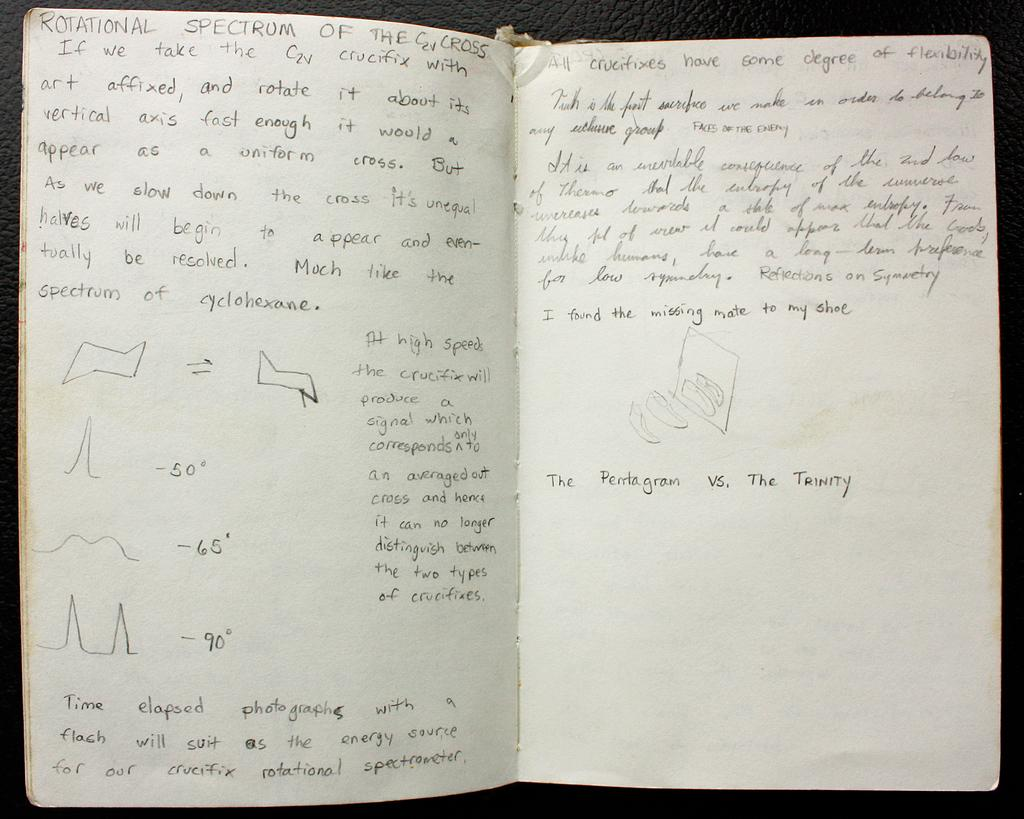<image>
Present a compact description of the photo's key features. A journal filled with writings about the crucifix and different theories. 